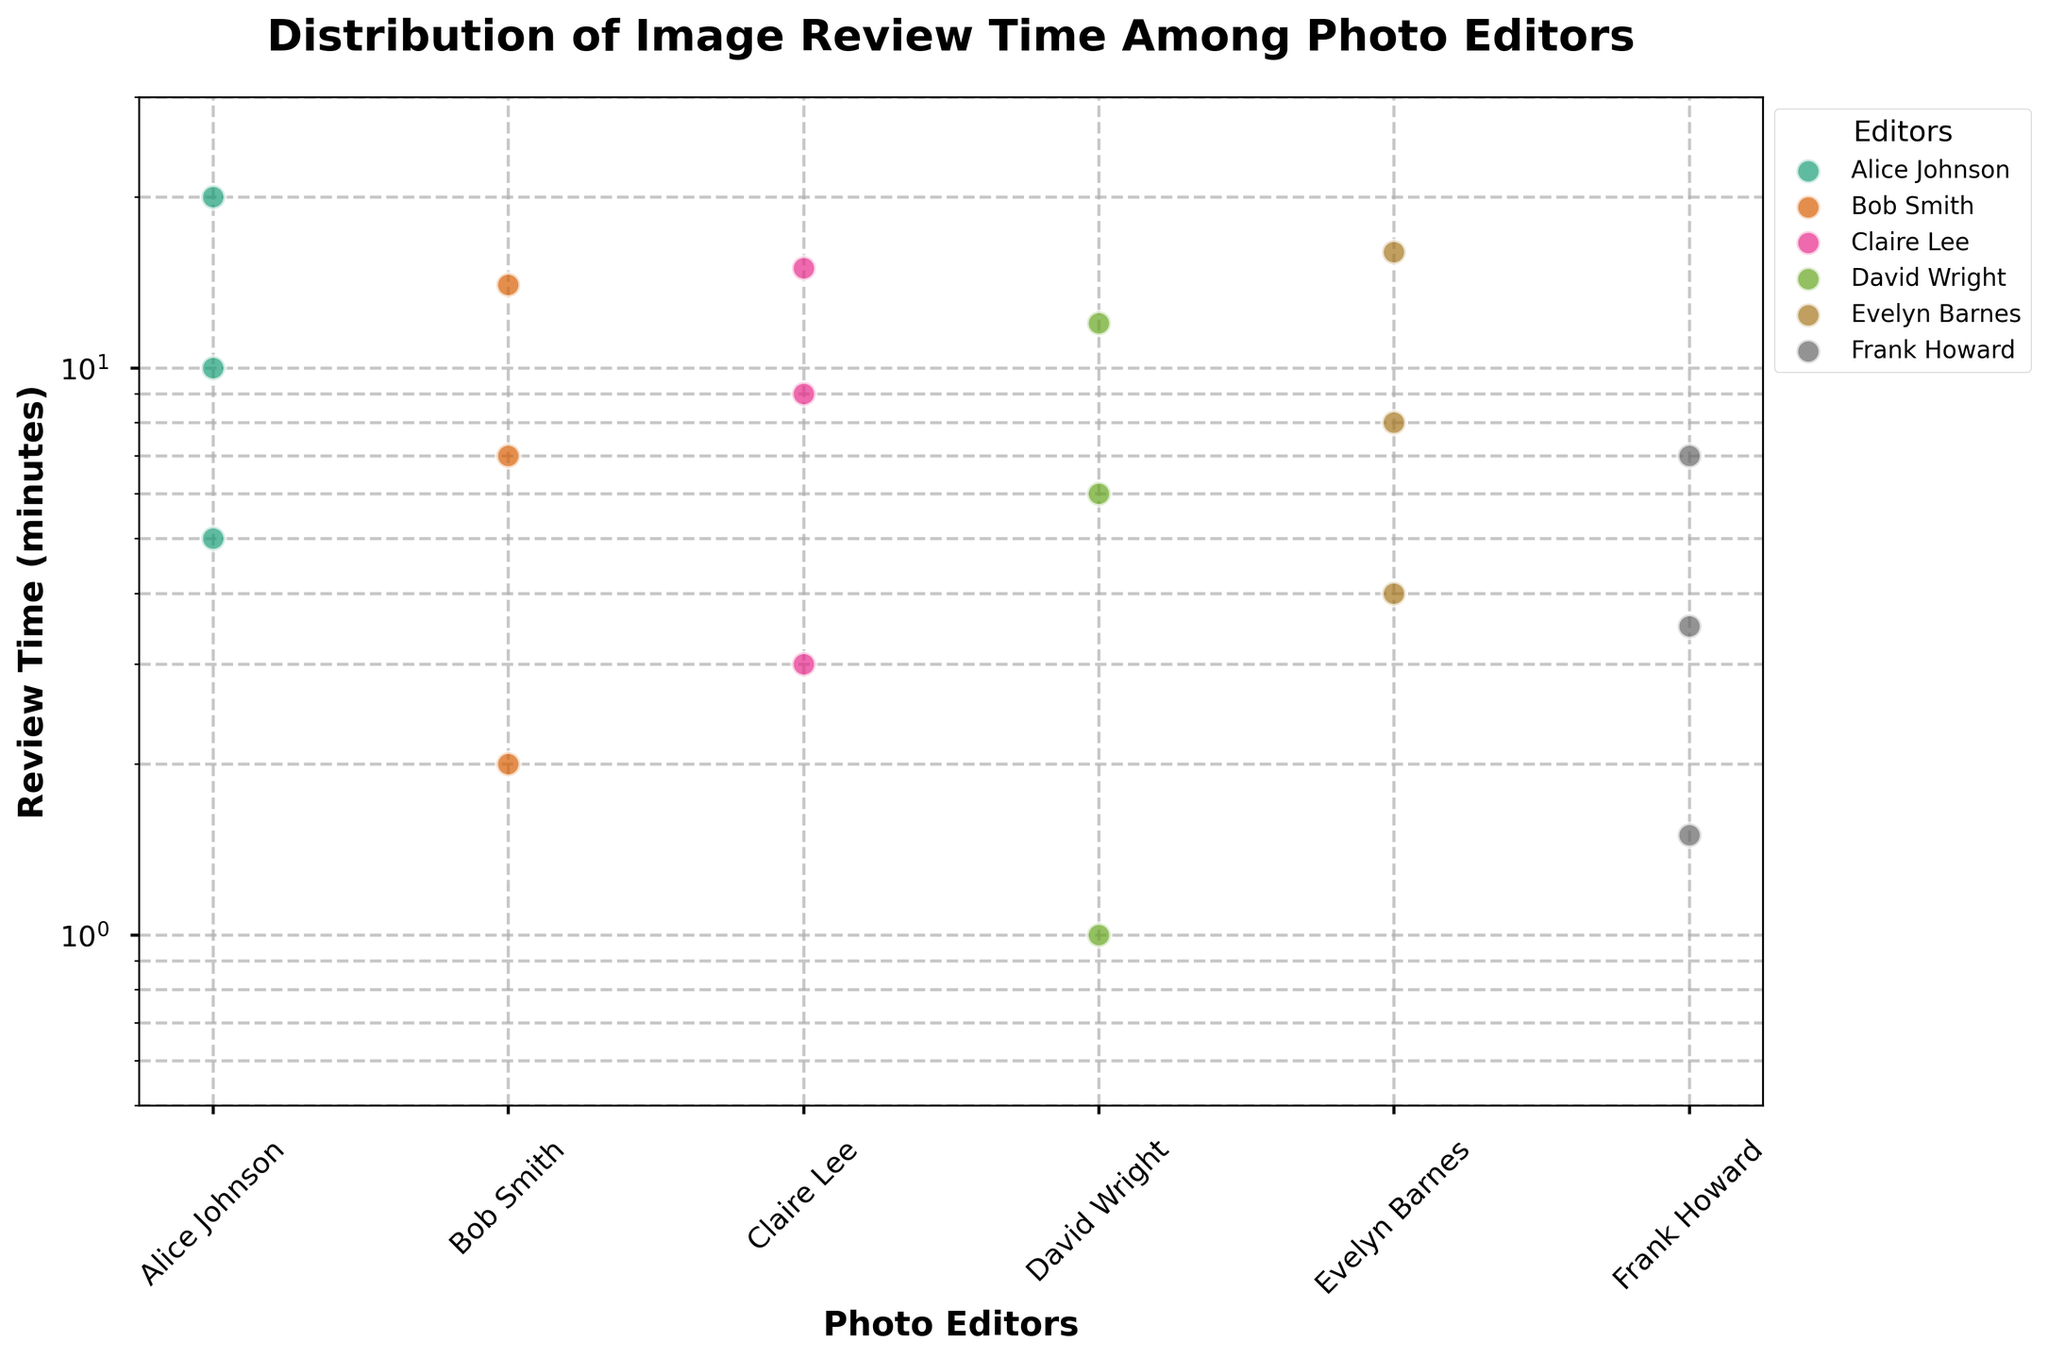What's the title of the plot? The title is prominently displayed at the top center of the plot. It reads "Distribution of Image Review Time Among Photo Editors".
Answer: Distribution of Image Review Time Among Photo Editors What's on the x-axis and y-axis? The x-axis is labeled "Photo Editors", and the y-axis is labeled "Review Time (minutes)". These labels describe what each axis represents.
Answer: x-axis: Photo Editors, y-axis: Review Time (minutes) Which editor has the shortest review time recorded? The shortest review time can be identified as the lowest data point on the y-axis. David Wright has the shortest review time with a value of 1 minute.
Answer: David Wright How many unique photo editors are there in the plot? By counting the number of unique names on the x-axis, we determine there are six unique photo editors: Alice Johnson, Bob Smith, Claire Lee, David Wright, Evelyn Barnes, and Frank Howard.
Answer: 6 What is the range of review times for Claire Lee? To find the range, subtract the minimum review time from the maximum review time for Claire Lee. She has review times of 3, 9, and 15 minutes. So, the range is 15 - 3 = 12 minutes.
Answer: 12 minutes Which editor reviewed images the most quickly on average? Calculate the average review time for each editor, then compare. For each editor:
- Alice Johnson: (5 + 10 + 20) / 3 = 11.67
- Bob Smith: (2 + 7 + 14) / 3 = 7.67
- Claire Lee: (3 + 9 + 15) / 3 = 9
- David Wright: (1 + 6 + 12) / 3 = 6.33
- Evelyn Barnes: (4 + 8 + 16) / 3 = 9.33
- Frank Howard: (1.5 + 3.5 + 7) / 3 = 4
Frank Howard has the lowest average review time of 4 minutes.
Answer: Frank Howard What is the median review time for Bob Smith? To find the median, list Bob Smith’s times in order: 2, 7, 14. The median is the middle value, which is 7.
Answer: 7 How does the y-axis scale affect the interpretation of review times? The y-axis uses a logarithmic scale, which means equal distances represent multiplicative rather than additive differences. This helps visualize a wide range of times more clearly and emphasizes relative rather than absolute differences.
Answer: Shows multiplicative differences Are any editors' review times clustered closely together? Yes, Bob Smith's and Evelyn Barnes' review times are closely clustered, particularly within the lower third of the y-axis range on a log scale, indicating lesser variance.
Answer: Bob Smith, Evelyn Barnes Which editor has the most spread out review times? By considering the vertical spread of data points for each editor, Alice Johnson's review times range from 5 to 20 minutes, showing the widest spread among the editors.
Answer: Alice Johnson 